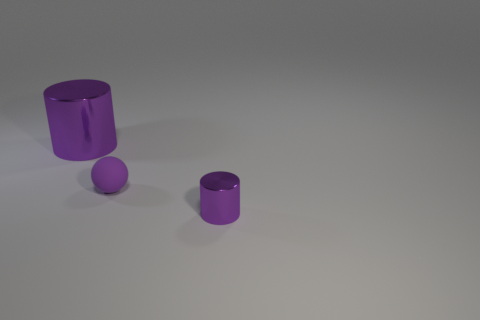Add 2 cyan rubber blocks. How many objects exist? 5 Subtract all cylinders. How many objects are left? 1 Add 1 tiny purple balls. How many tiny purple balls exist? 2 Subtract 0 blue blocks. How many objects are left? 3 Subtract all tiny red objects. Subtract all rubber spheres. How many objects are left? 2 Add 2 big purple objects. How many big purple objects are left? 3 